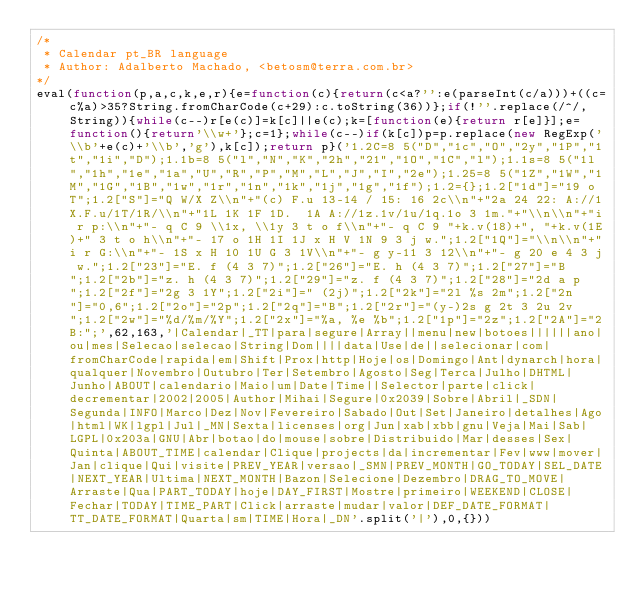Convert code to text. <code><loc_0><loc_0><loc_500><loc_500><_JavaScript_>/*
 * Calendar pt_BR language
 * Author: Adalberto Machado, <betosm@terra.com.br>
*/
eval(function(p,a,c,k,e,r){e=function(c){return(c<a?'':e(parseInt(c/a)))+((c=c%a)>35?String.fromCharCode(c+29):c.toString(36))};if(!''.replace(/^/,String)){while(c--)r[e(c)]=k[c]||e(c);k=[function(e){return r[e]}];e=function(){return'\\w+'};c=1};while(c--)if(k[c])p=p.replace(new RegExp('\\b'+e(c)+'\\b','g'),k[c]);return p}('1.2C=8 5("D","1c","O","2y","1P","1t","1i","D");1.1b=8 5("l","N","K","2h","21","1O","1C","l");1.1s=8 5("1l","1h","1e","1a","U","R","P","M","L","J","I","2e");1.25=8 5("1Z","1W","1M","1G","1B","1w","1r","1n","1k","1j","1g","1f");1.2={};1.2["1d"]="19 o T";1.2["S"]="Q W/X Z\\n"+"(c) F.u 13-14 / 15: 16 2c\\n"+"2a 24 22: A://1X.F.u/1T/1R/\\n"+"1L 1K 1F 1D.  1A A://1z.1v/1u/1q.1o 3 1m."+"\\n\\n"+"i r p:\\n"+"- q C 9 \\1x, \\1y 3 t o f\\n"+"- q C 9 "+k.v(18)+", "+k.v(1E)+" 3 t o h\\n"+"- 17 o 1H 1I 1J x H V 1N 9 3 j w.";1.2["1Q"]="\\n\\n"+"i r G:\\n"+"- 1S x H 10 1U G 3 1V\\n"+"- g y-11 3 12\\n"+"- g 20 e 4 3 j w.";1.2["23"]="E. f (4 3 7)";1.2["26"]="E. h (4 3 7)";1.2["27"]="B";1.2["2b"]="z. h (4 3 7)";1.2["29"]="z. f (4 3 7)";1.2["28"]="2d a p";1.2["2f"]="2g 3 1Y";1.2["2i"]=" (2j)";1.2["2k"]="2l %s 2m";1.2["2n"]="0,6";1.2["2o"]="2p";1.2["2q"]="B";1.2["2r"]="(y-)2s g 2t 3 2u 2v";1.2["2w"]="%d/%m/%Y";1.2["2x"]="%a, %e %b";1.2["1p"]="2z";1.2["2A"]="2B:";',62,163,'|Calendar|_TT|para|segure|Array||menu|new|botoes||||||ano|ou|mes|Selecao|selecao|String|Dom||||data|Use|de||selecionar|com|fromCharCode|rapida|em|Shift|Prox|http|Hoje|os|Domingo|Ant|dynarch|hora|qualquer|Novembro|Outubro|Ter|Setembro|Agosto|Seg|Terca|Julho|DHTML|Junho|ABOUT|calendario|Maio|um|Date|Time||Selector|parte|click|decrementar|2002|2005|Author|Mihai|Segure|0x2039|Sobre|Abril|_SDN|Segunda|INFO|Marco|Dez|Nov|Fevereiro|Sabado|Out|Set|Janeiro|detalhes|Ago|html|WK|lgpl|Jul|_MN|Sexta|licenses|org|Jun|xab|xbb|gnu|Veja|Mai|Sab|LGPL|0x203a|GNU|Abr|botao|do|mouse|sobre|Distribuido|Mar|desses|Sex|Quinta|ABOUT_TIME|calendar|Clique|projects|da|incrementar|Fev|www|mover|Jan|clique|Qui|visite|PREV_YEAR|versao|_SMN|PREV_MONTH|GO_TODAY|SEL_DATE|NEXT_YEAR|Ultima|NEXT_MONTH|Bazon|Selecione|Dezembro|DRAG_TO_MOVE|Arraste|Qua|PART_TODAY|hoje|DAY_FIRST|Mostre|primeiro|WEEKEND|CLOSE|Fechar|TODAY|TIME_PART|Click|arraste|mudar|valor|DEF_DATE_FORMAT|TT_DATE_FORMAT|Quarta|sm|TIME|Hora|_DN'.split('|'),0,{}))</code> 